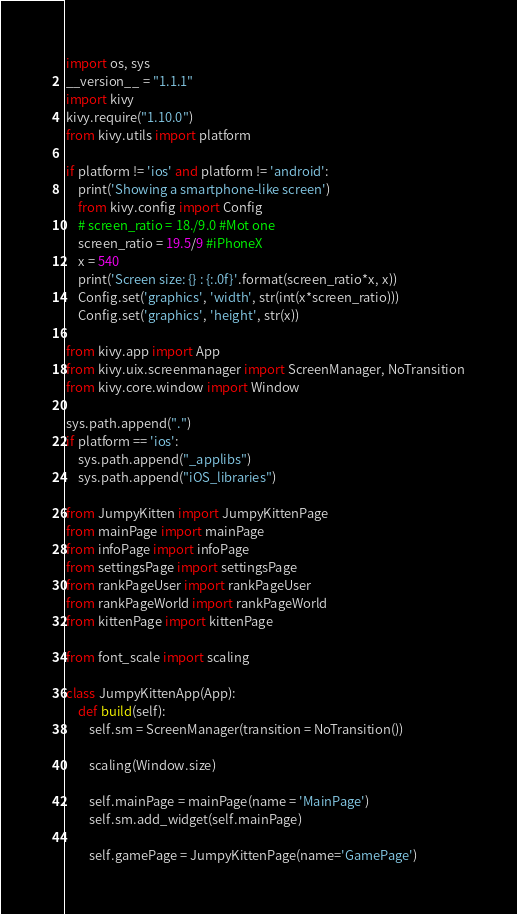<code> <loc_0><loc_0><loc_500><loc_500><_Python_>import os, sys
__version__ = "1.1.1"
import kivy
kivy.require("1.10.0")
from kivy.utils import platform

if platform != 'ios' and platform != 'android':
	print('Showing a smartphone-like screen')
	from kivy.config import Config
	# screen_ratio = 18./9.0 #Mot one
	screen_ratio = 19.5/9 #iPhoneX
	x = 540
	print('Screen size: {} : {:.0f}'.format(screen_ratio*x, x))
	Config.set('graphics', 'width', str(int(x*screen_ratio)))
	Config.set('graphics', 'height', str(x))

from kivy.app import App
from kivy.uix.screenmanager import ScreenManager, NoTransition
from kivy.core.window import Window

sys.path.append(".")
if platform == 'ios':
	sys.path.append("_applibs")
	sys.path.append("iOS_libraries")

from JumpyKitten import JumpyKittenPage
from mainPage import mainPage
from infoPage import infoPage
from settingsPage import settingsPage
from rankPageUser import rankPageUser
from rankPageWorld import rankPageWorld
from kittenPage import kittenPage

from font_scale import scaling

class JumpyKittenApp(App):
	def build(self):
		self.sm = ScreenManager(transition = NoTransition())

		scaling(Window.size)

		self.mainPage = mainPage(name = 'MainPage')
		self.sm.add_widget(self.mainPage)

		self.gamePage = JumpyKittenPage(name='GamePage')</code> 